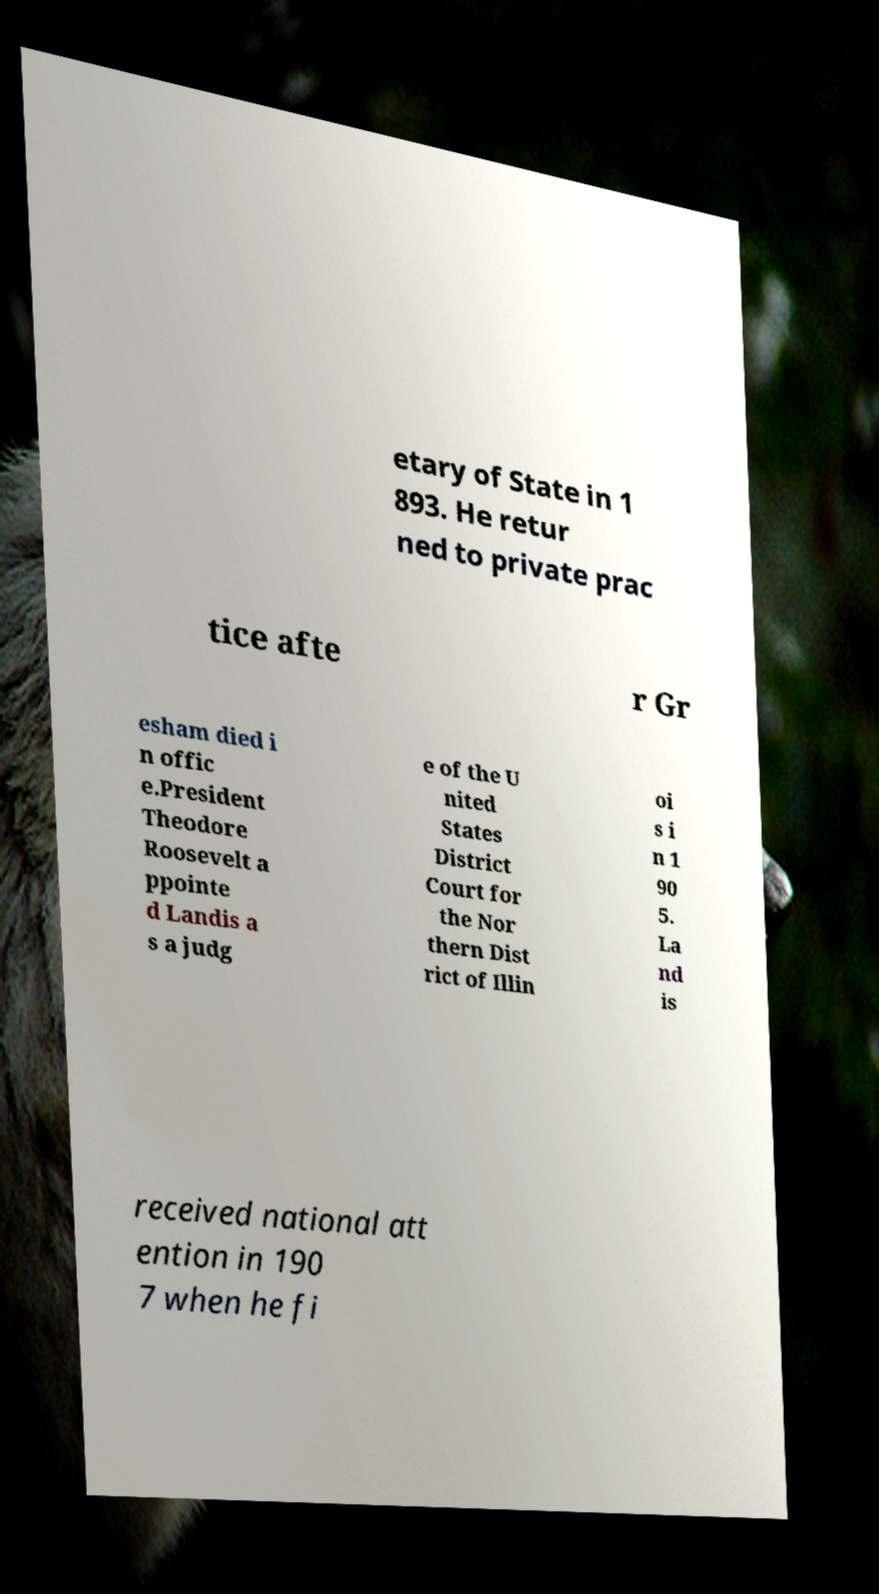Can you accurately transcribe the text from the provided image for me? etary of State in 1 893. He retur ned to private prac tice afte r Gr esham died i n offic e.President Theodore Roosevelt a ppointe d Landis a s a judg e of the U nited States District Court for the Nor thern Dist rict of Illin oi s i n 1 90 5. La nd is received national att ention in 190 7 when he fi 